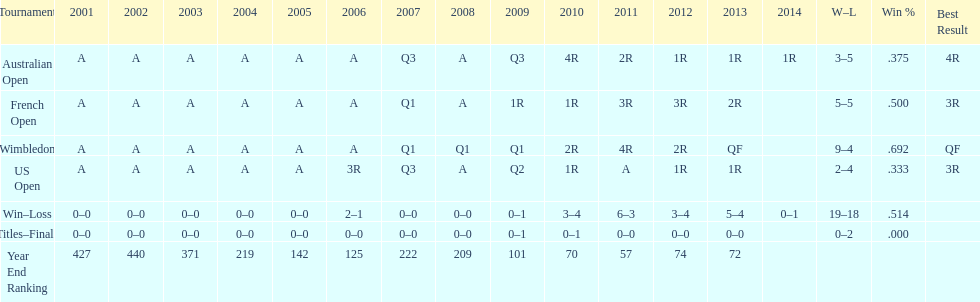What tournament has 5-5 as it's "w-l" record? French Open. 